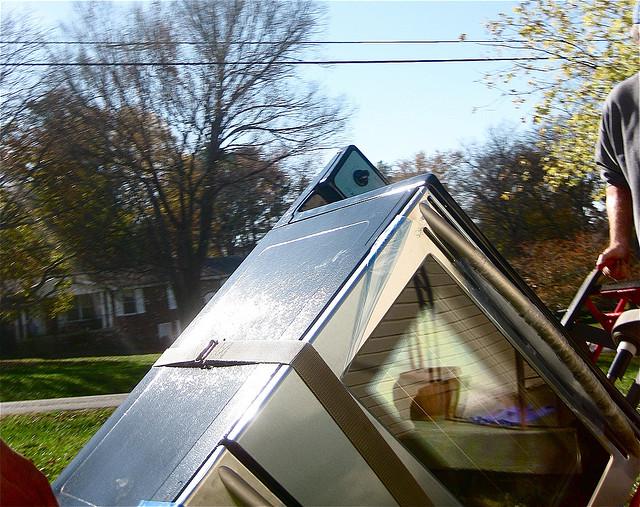What room of the house does this item belong in?
Give a very brief answer. Kitchen. What is the man rolling around?
Concise answer only. Oven. Is this oven built for outdoor use?
Answer briefly. No. What color is the sky?
Give a very brief answer. Blue. Are there clouds in the sky?
Write a very short answer. No. 